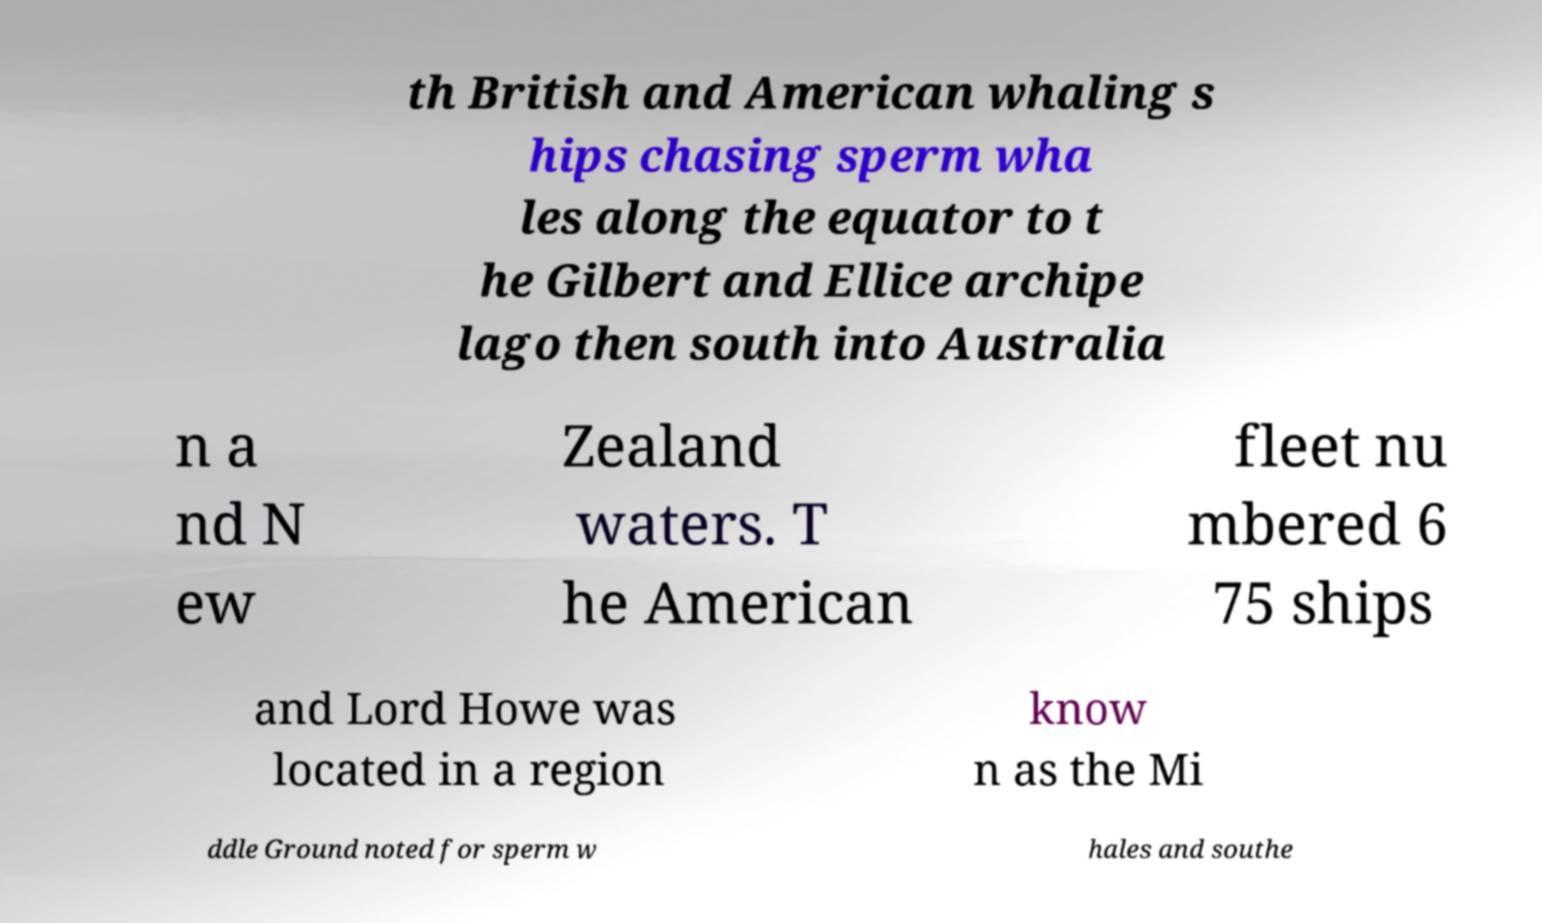Can you accurately transcribe the text from the provided image for me? th British and American whaling s hips chasing sperm wha les along the equator to t he Gilbert and Ellice archipe lago then south into Australia n a nd N ew Zealand waters. T he American fleet nu mbered 6 75 ships and Lord Howe was located in a region know n as the Mi ddle Ground noted for sperm w hales and southe 